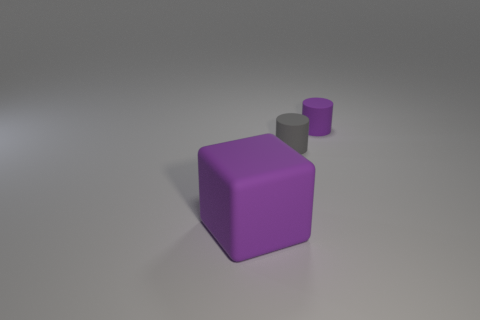Is the number of purple cylinders that are behind the gray cylinder greater than the number of small brown rubber balls?
Give a very brief answer. Yes. Is the shape of the small gray object the same as the tiny purple thing?
Provide a short and direct response. Yes. What size is the gray matte cylinder?
Keep it short and to the point. Small. Is the number of tiny matte cylinders on the right side of the small gray object greater than the number of large matte cubes that are to the left of the large purple rubber cube?
Your answer should be compact. Yes. Are there any purple rubber objects to the right of the gray rubber thing?
Ensure brevity in your answer.  Yes. Are there any gray rubber cylinders that have the same size as the purple matte cylinder?
Make the answer very short. Yes. There is another cylinder that is made of the same material as the small gray cylinder; what is its color?
Ensure brevity in your answer.  Purple. What material is the big object?
Your answer should be very brief. Rubber. What is the shape of the gray rubber thing?
Ensure brevity in your answer.  Cylinder. How many other rubber objects have the same color as the large matte object?
Your answer should be compact. 1. 